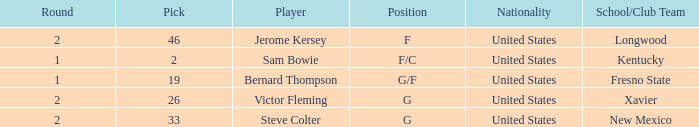What is Player, when Round is "2", and when School/Club Team is "Xavier"? Victor Fleming. 